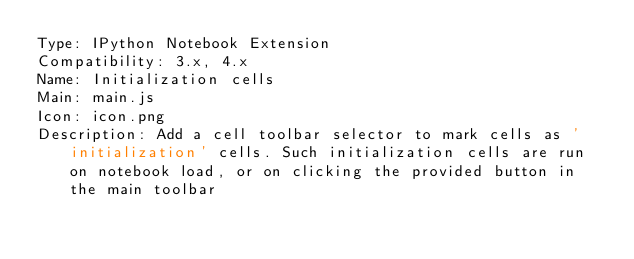Convert code to text. <code><loc_0><loc_0><loc_500><loc_500><_YAML_>Type: IPython Notebook Extension
Compatibility: 3.x, 4.x
Name: Initialization cells
Main: main.js
Icon: icon.png
Description: Add a cell toolbar selector to mark cells as 'initialization' cells. Such initialization cells are run on notebook load, or on clicking the provided button in the main toolbar
</code> 